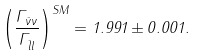<formula> <loc_0><loc_0><loc_500><loc_500>\left ( \frac { \Gamma _ { \bar { \nu } \nu } } { \Gamma _ { \bar { l } l } } \right ) ^ { S M } = 1 . 9 9 1 \pm 0 . 0 0 1 .</formula> 